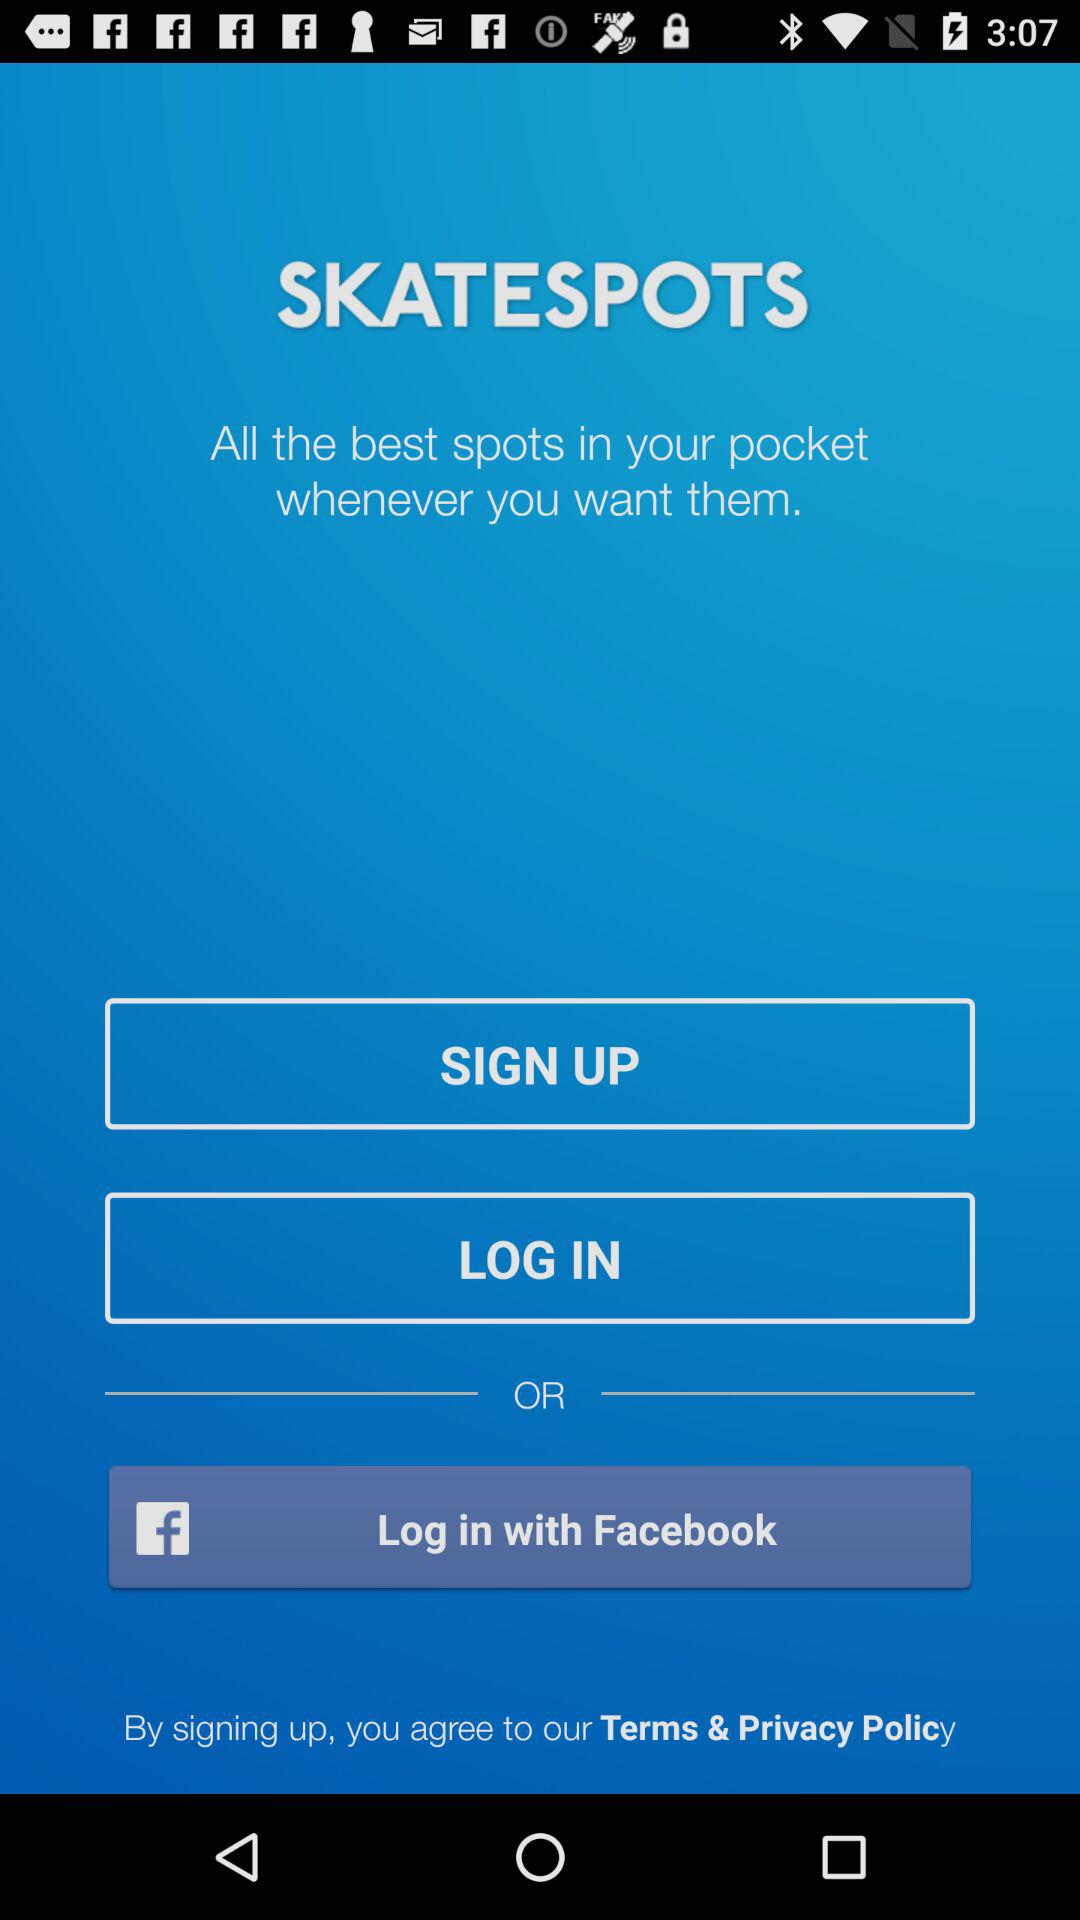What is the name of the application? The name of the application is "SKATESPOTS". 